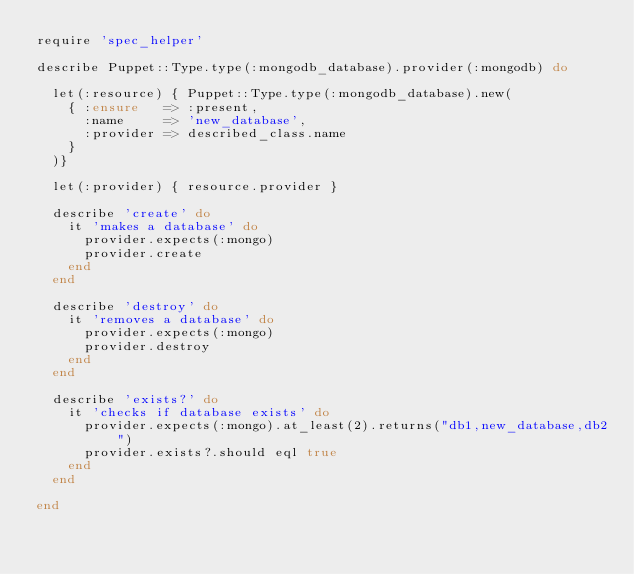Convert code to text. <code><loc_0><loc_0><loc_500><loc_500><_Ruby_>require 'spec_helper'

describe Puppet::Type.type(:mongodb_database).provider(:mongodb) do

  let(:resource) { Puppet::Type.type(:mongodb_database).new(
    { :ensure   => :present,
      :name     => 'new_database',
      :provider => described_class.name
    }
  )}

  let(:provider) { resource.provider }

  describe 'create' do
    it 'makes a database' do
      provider.expects(:mongo)
      provider.create
    end
  end

  describe 'destroy' do
    it 'removes a database' do
      provider.expects(:mongo)
      provider.destroy
    end
  end

  describe 'exists?' do
    it 'checks if database exists' do
      provider.expects(:mongo).at_least(2).returns("db1,new_database,db2")
      provider.exists?.should eql true
    end
  end

end
</code> 